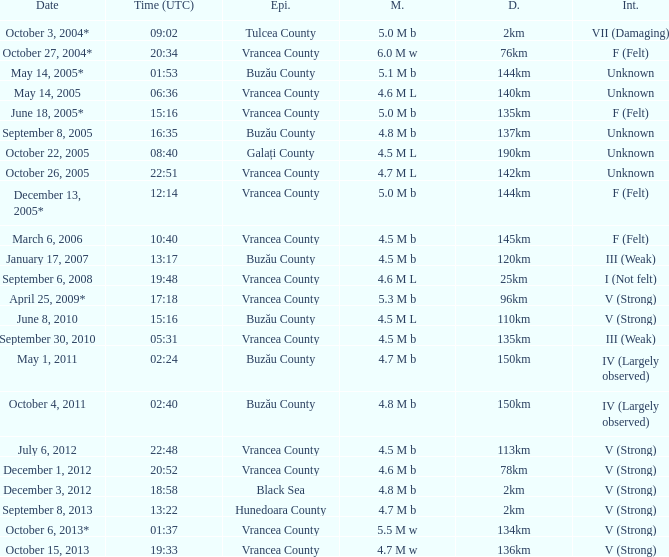What is the depth of the quake that occurred at 19:48? 25km. 